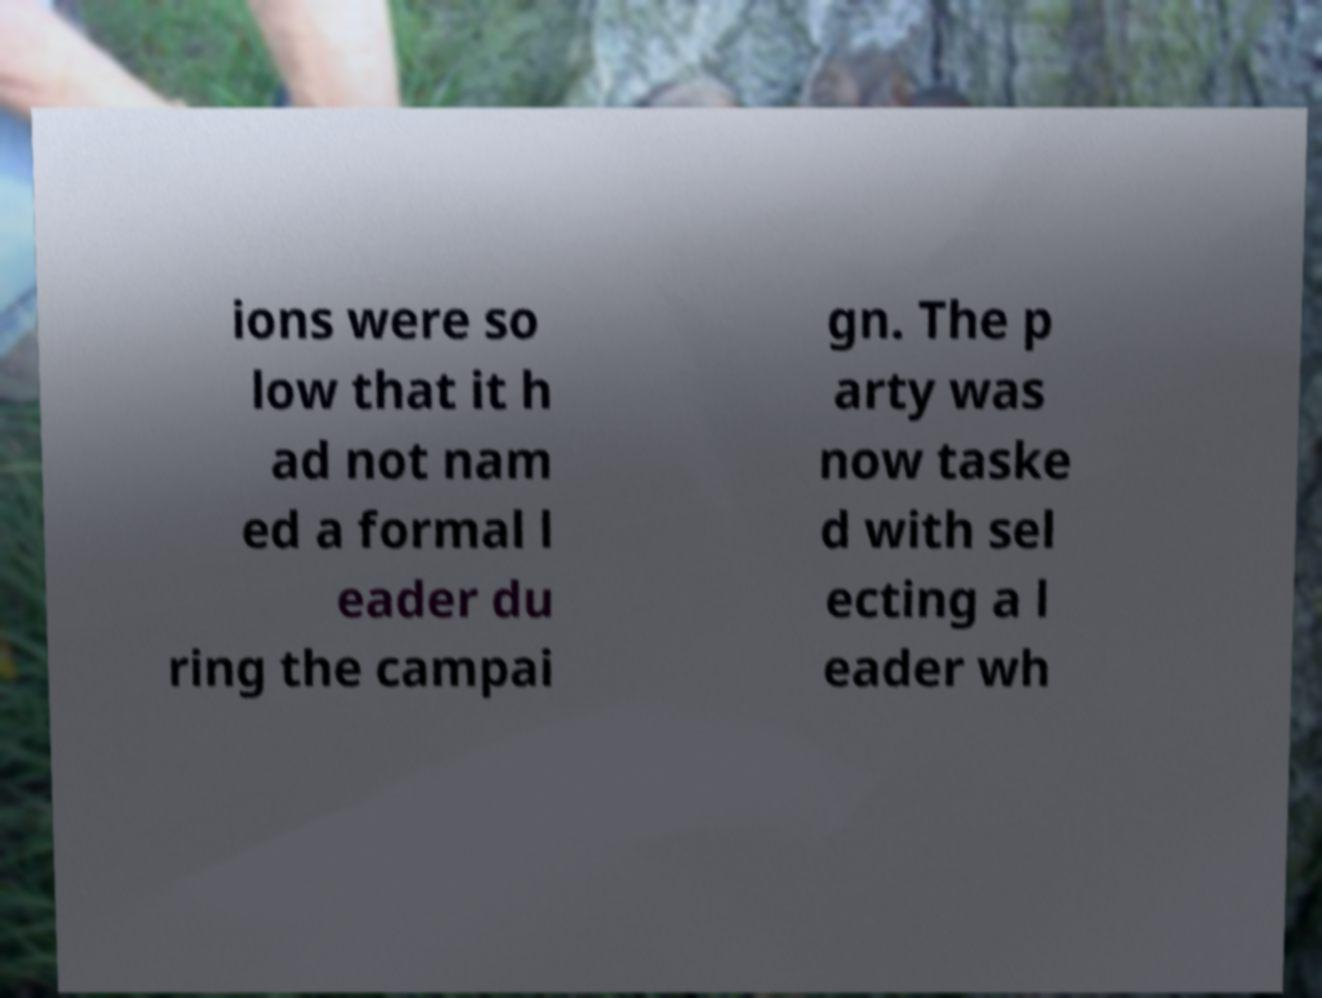Can you read and provide the text displayed in the image?This photo seems to have some interesting text. Can you extract and type it out for me? ions were so low that it h ad not nam ed a formal l eader du ring the campai gn. The p arty was now taske d with sel ecting a l eader wh 